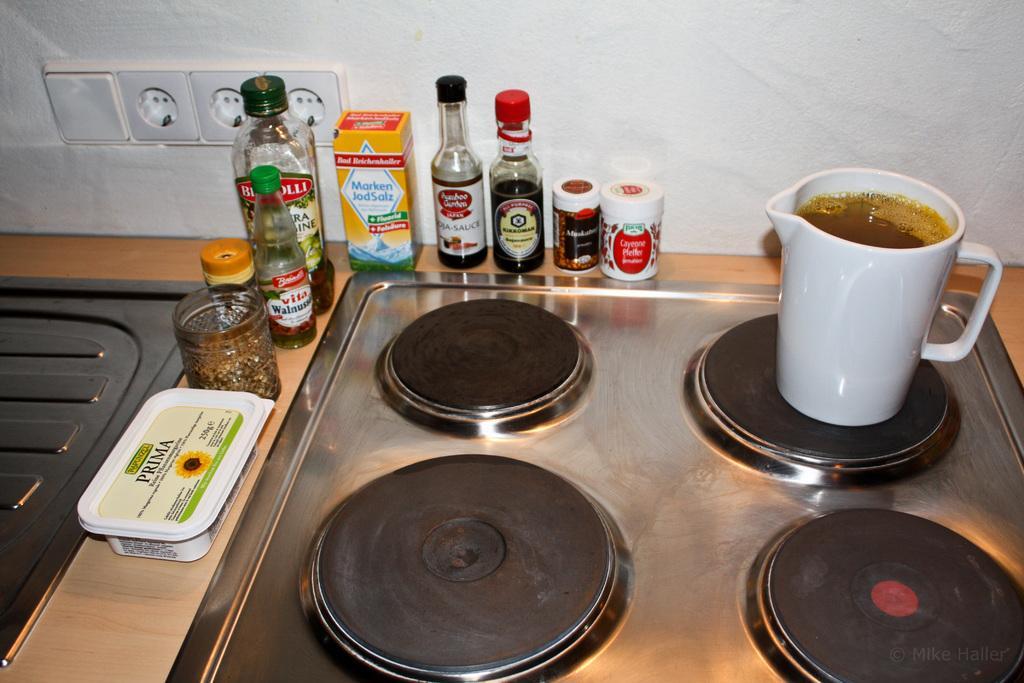How would you summarize this image in a sentence or two? In this image, we can see some objects like bottles, a mug, a container. We can also see some black colored objects. In the background, we can see the wall with an object attached. 